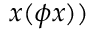Convert formula to latex. <formula><loc_0><loc_0><loc_500><loc_500>x ( \phi x ) )</formula> 